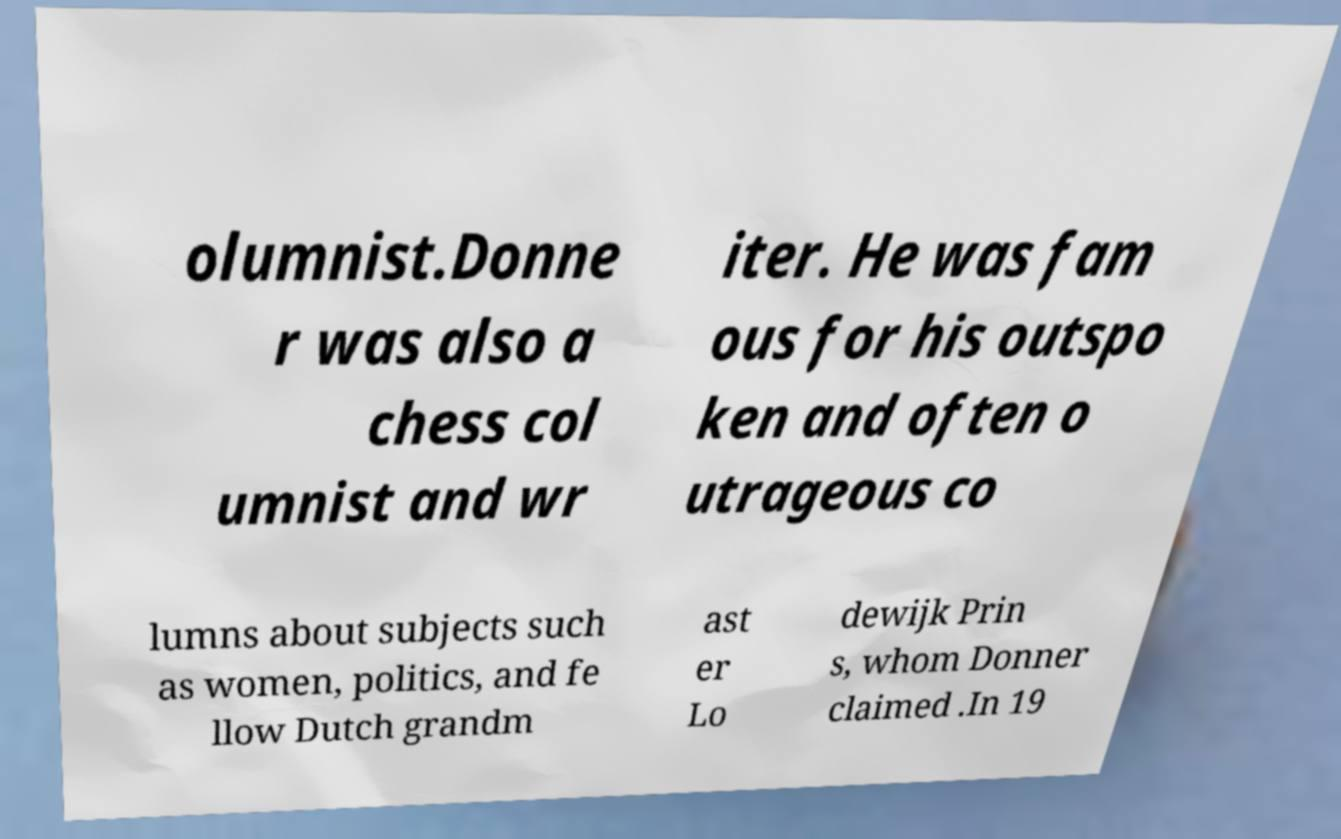What messages or text are displayed in this image? I need them in a readable, typed format. olumnist.Donne r was also a chess col umnist and wr iter. He was fam ous for his outspo ken and often o utrageous co lumns about subjects such as women, politics, and fe llow Dutch grandm ast er Lo dewijk Prin s, whom Donner claimed .In 19 